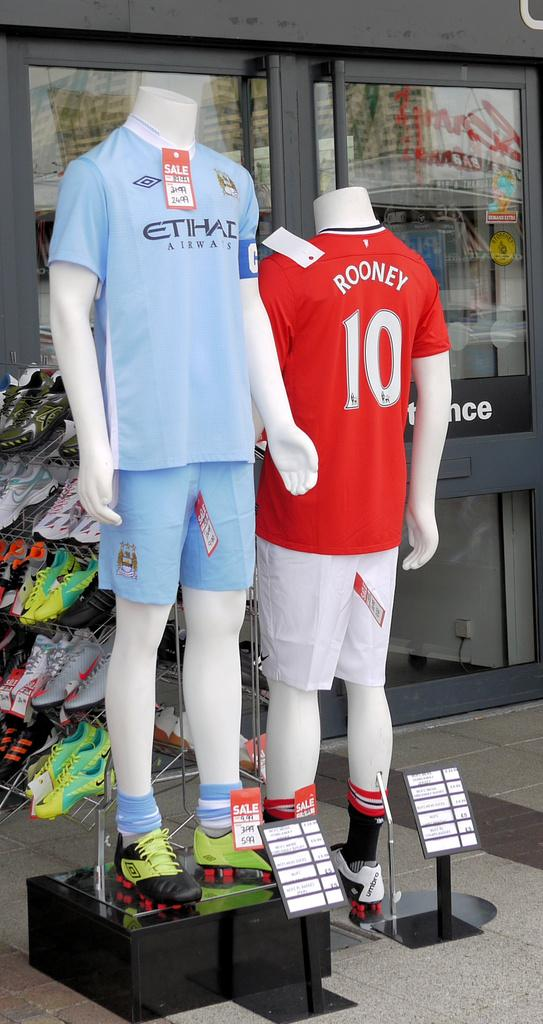<image>
Summarize the visual content of the image. a jersey that is red and has the number 10 on it 